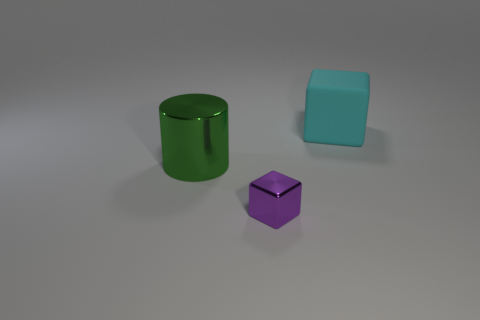Add 2 big green metal cylinders. How many objects exist? 5 Subtract all blocks. How many objects are left? 1 Subtract all metal cylinders. Subtract all metal blocks. How many objects are left? 1 Add 1 big green shiny cylinders. How many big green shiny cylinders are left? 2 Add 3 green metallic objects. How many green metallic objects exist? 4 Subtract 0 cyan cylinders. How many objects are left? 3 